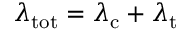Convert formula to latex. <formula><loc_0><loc_0><loc_500><loc_500>\lambda _ { t o t } = \lambda _ { c } + \lambda _ { t }</formula> 